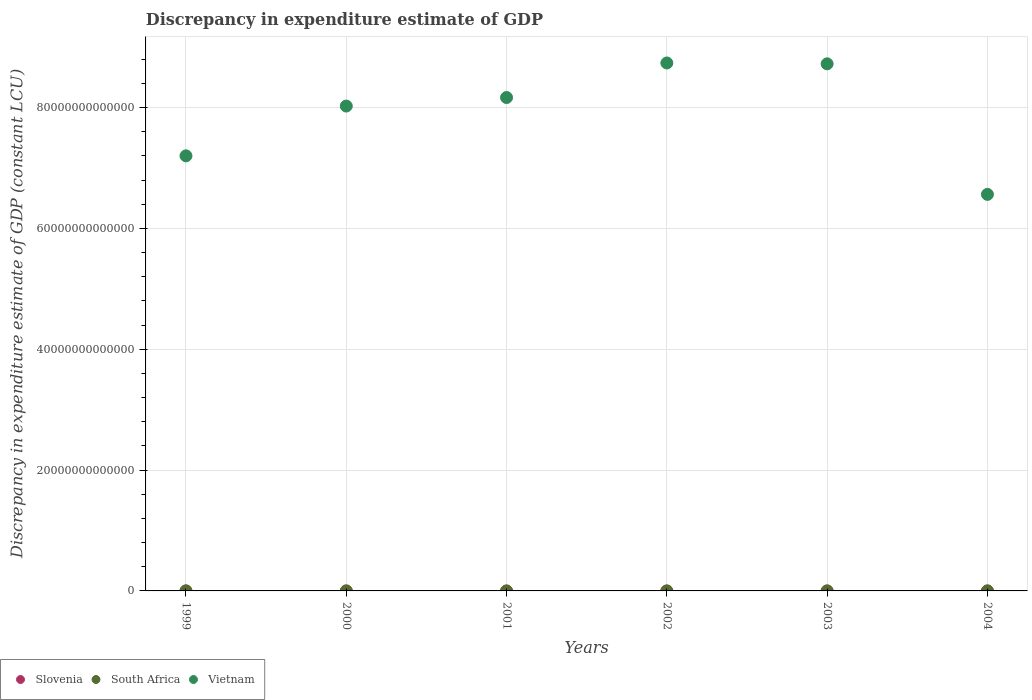What is the discrepancy in expenditure estimate of GDP in Slovenia in 2000?
Your answer should be compact. 0. Across all years, what is the maximum discrepancy in expenditure estimate of GDP in South Africa?
Your answer should be compact. 1.17e+09. What is the total discrepancy in expenditure estimate of GDP in Slovenia in the graph?
Your answer should be very brief. 0. What is the difference between the discrepancy in expenditure estimate of GDP in Vietnam in 2002 and that in 2003?
Give a very brief answer. 1.40e+11. What is the difference between the discrepancy in expenditure estimate of GDP in Slovenia in 2002 and the discrepancy in expenditure estimate of GDP in South Africa in 2001?
Provide a succinct answer. 0. What is the average discrepancy in expenditure estimate of GDP in South Africa per year?
Provide a succinct answer. 1.95e+08. What is the ratio of the discrepancy in expenditure estimate of GDP in Vietnam in 2002 to that in 2003?
Make the answer very short. 1. Is the discrepancy in expenditure estimate of GDP in Vietnam in 2001 less than that in 2004?
Offer a terse response. No. What is the difference between the highest and the second highest discrepancy in expenditure estimate of GDP in Vietnam?
Provide a succinct answer. 1.40e+11. What is the difference between the highest and the lowest discrepancy in expenditure estimate of GDP in South Africa?
Your response must be concise. 1.17e+09. In how many years, is the discrepancy in expenditure estimate of GDP in Slovenia greater than the average discrepancy in expenditure estimate of GDP in Slovenia taken over all years?
Make the answer very short. 0. Does the discrepancy in expenditure estimate of GDP in Vietnam monotonically increase over the years?
Ensure brevity in your answer.  No. Is the discrepancy in expenditure estimate of GDP in Slovenia strictly greater than the discrepancy in expenditure estimate of GDP in Vietnam over the years?
Give a very brief answer. No. How many dotlines are there?
Make the answer very short. 2. How many years are there in the graph?
Your response must be concise. 6. What is the difference between two consecutive major ticks on the Y-axis?
Your answer should be very brief. 2.00e+13. Are the values on the major ticks of Y-axis written in scientific E-notation?
Make the answer very short. No. Does the graph contain any zero values?
Offer a very short reply. Yes. How are the legend labels stacked?
Provide a short and direct response. Horizontal. What is the title of the graph?
Provide a short and direct response. Discrepancy in expenditure estimate of GDP. Does "Sint Maarten (Dutch part)" appear as one of the legend labels in the graph?
Ensure brevity in your answer.  No. What is the label or title of the Y-axis?
Provide a succinct answer. Discrepancy in expenditure estimate of GDP (constant LCU). What is the Discrepancy in expenditure estimate of GDP (constant LCU) in South Africa in 1999?
Offer a terse response. 1.17e+09. What is the Discrepancy in expenditure estimate of GDP (constant LCU) in Vietnam in 1999?
Give a very brief answer. 7.20e+13. What is the Discrepancy in expenditure estimate of GDP (constant LCU) in Slovenia in 2000?
Make the answer very short. 0. What is the Discrepancy in expenditure estimate of GDP (constant LCU) of Vietnam in 2000?
Your answer should be compact. 8.02e+13. What is the Discrepancy in expenditure estimate of GDP (constant LCU) of Slovenia in 2001?
Your response must be concise. 0. What is the Discrepancy in expenditure estimate of GDP (constant LCU) of Vietnam in 2001?
Give a very brief answer. 8.16e+13. What is the Discrepancy in expenditure estimate of GDP (constant LCU) of Vietnam in 2002?
Offer a terse response. 8.74e+13. What is the Discrepancy in expenditure estimate of GDP (constant LCU) of Slovenia in 2003?
Your response must be concise. 0. What is the Discrepancy in expenditure estimate of GDP (constant LCU) in Vietnam in 2003?
Your answer should be very brief. 8.72e+13. What is the Discrepancy in expenditure estimate of GDP (constant LCU) of South Africa in 2004?
Offer a very short reply. 0. What is the Discrepancy in expenditure estimate of GDP (constant LCU) in Vietnam in 2004?
Your response must be concise. 6.56e+13. Across all years, what is the maximum Discrepancy in expenditure estimate of GDP (constant LCU) in South Africa?
Provide a short and direct response. 1.17e+09. Across all years, what is the maximum Discrepancy in expenditure estimate of GDP (constant LCU) of Vietnam?
Provide a succinct answer. 8.74e+13. Across all years, what is the minimum Discrepancy in expenditure estimate of GDP (constant LCU) in South Africa?
Keep it short and to the point. 0. Across all years, what is the minimum Discrepancy in expenditure estimate of GDP (constant LCU) of Vietnam?
Your answer should be compact. 6.56e+13. What is the total Discrepancy in expenditure estimate of GDP (constant LCU) of Slovenia in the graph?
Ensure brevity in your answer.  0. What is the total Discrepancy in expenditure estimate of GDP (constant LCU) in South Africa in the graph?
Your response must be concise. 1.17e+09. What is the total Discrepancy in expenditure estimate of GDP (constant LCU) of Vietnam in the graph?
Keep it short and to the point. 4.74e+14. What is the difference between the Discrepancy in expenditure estimate of GDP (constant LCU) of Vietnam in 1999 and that in 2000?
Offer a terse response. -8.24e+12. What is the difference between the Discrepancy in expenditure estimate of GDP (constant LCU) of Vietnam in 1999 and that in 2001?
Provide a short and direct response. -9.65e+12. What is the difference between the Discrepancy in expenditure estimate of GDP (constant LCU) of Vietnam in 1999 and that in 2002?
Offer a terse response. -1.54e+13. What is the difference between the Discrepancy in expenditure estimate of GDP (constant LCU) in Vietnam in 1999 and that in 2003?
Ensure brevity in your answer.  -1.52e+13. What is the difference between the Discrepancy in expenditure estimate of GDP (constant LCU) of Vietnam in 1999 and that in 2004?
Offer a very short reply. 6.38e+12. What is the difference between the Discrepancy in expenditure estimate of GDP (constant LCU) in Vietnam in 2000 and that in 2001?
Give a very brief answer. -1.41e+12. What is the difference between the Discrepancy in expenditure estimate of GDP (constant LCU) in Vietnam in 2000 and that in 2002?
Ensure brevity in your answer.  -7.13e+12. What is the difference between the Discrepancy in expenditure estimate of GDP (constant LCU) of Vietnam in 2000 and that in 2003?
Give a very brief answer. -6.99e+12. What is the difference between the Discrepancy in expenditure estimate of GDP (constant LCU) of Vietnam in 2000 and that in 2004?
Give a very brief answer. 1.46e+13. What is the difference between the Discrepancy in expenditure estimate of GDP (constant LCU) in Vietnam in 2001 and that in 2002?
Give a very brief answer. -5.72e+12. What is the difference between the Discrepancy in expenditure estimate of GDP (constant LCU) in Vietnam in 2001 and that in 2003?
Give a very brief answer. -5.58e+12. What is the difference between the Discrepancy in expenditure estimate of GDP (constant LCU) in Vietnam in 2001 and that in 2004?
Keep it short and to the point. 1.60e+13. What is the difference between the Discrepancy in expenditure estimate of GDP (constant LCU) in Vietnam in 2002 and that in 2003?
Provide a succinct answer. 1.40e+11. What is the difference between the Discrepancy in expenditure estimate of GDP (constant LCU) of Vietnam in 2002 and that in 2004?
Your answer should be very brief. 2.17e+13. What is the difference between the Discrepancy in expenditure estimate of GDP (constant LCU) of Vietnam in 2003 and that in 2004?
Provide a succinct answer. 2.16e+13. What is the difference between the Discrepancy in expenditure estimate of GDP (constant LCU) in South Africa in 1999 and the Discrepancy in expenditure estimate of GDP (constant LCU) in Vietnam in 2000?
Offer a terse response. -8.02e+13. What is the difference between the Discrepancy in expenditure estimate of GDP (constant LCU) in South Africa in 1999 and the Discrepancy in expenditure estimate of GDP (constant LCU) in Vietnam in 2001?
Your answer should be compact. -8.16e+13. What is the difference between the Discrepancy in expenditure estimate of GDP (constant LCU) of South Africa in 1999 and the Discrepancy in expenditure estimate of GDP (constant LCU) of Vietnam in 2002?
Your response must be concise. -8.74e+13. What is the difference between the Discrepancy in expenditure estimate of GDP (constant LCU) in South Africa in 1999 and the Discrepancy in expenditure estimate of GDP (constant LCU) in Vietnam in 2003?
Offer a terse response. -8.72e+13. What is the difference between the Discrepancy in expenditure estimate of GDP (constant LCU) in South Africa in 1999 and the Discrepancy in expenditure estimate of GDP (constant LCU) in Vietnam in 2004?
Your answer should be very brief. -6.56e+13. What is the average Discrepancy in expenditure estimate of GDP (constant LCU) in South Africa per year?
Provide a short and direct response. 1.95e+08. What is the average Discrepancy in expenditure estimate of GDP (constant LCU) in Vietnam per year?
Offer a very short reply. 7.90e+13. In the year 1999, what is the difference between the Discrepancy in expenditure estimate of GDP (constant LCU) of South Africa and Discrepancy in expenditure estimate of GDP (constant LCU) of Vietnam?
Provide a succinct answer. -7.20e+13. What is the ratio of the Discrepancy in expenditure estimate of GDP (constant LCU) in Vietnam in 1999 to that in 2000?
Keep it short and to the point. 0.9. What is the ratio of the Discrepancy in expenditure estimate of GDP (constant LCU) of Vietnam in 1999 to that in 2001?
Make the answer very short. 0.88. What is the ratio of the Discrepancy in expenditure estimate of GDP (constant LCU) in Vietnam in 1999 to that in 2002?
Offer a terse response. 0.82. What is the ratio of the Discrepancy in expenditure estimate of GDP (constant LCU) in Vietnam in 1999 to that in 2003?
Offer a very short reply. 0.83. What is the ratio of the Discrepancy in expenditure estimate of GDP (constant LCU) in Vietnam in 1999 to that in 2004?
Make the answer very short. 1.1. What is the ratio of the Discrepancy in expenditure estimate of GDP (constant LCU) of Vietnam in 2000 to that in 2001?
Provide a short and direct response. 0.98. What is the ratio of the Discrepancy in expenditure estimate of GDP (constant LCU) in Vietnam in 2000 to that in 2002?
Offer a terse response. 0.92. What is the ratio of the Discrepancy in expenditure estimate of GDP (constant LCU) in Vietnam in 2000 to that in 2003?
Your answer should be very brief. 0.92. What is the ratio of the Discrepancy in expenditure estimate of GDP (constant LCU) of Vietnam in 2000 to that in 2004?
Provide a short and direct response. 1.22. What is the ratio of the Discrepancy in expenditure estimate of GDP (constant LCU) of Vietnam in 2001 to that in 2002?
Keep it short and to the point. 0.93. What is the ratio of the Discrepancy in expenditure estimate of GDP (constant LCU) in Vietnam in 2001 to that in 2003?
Provide a short and direct response. 0.94. What is the ratio of the Discrepancy in expenditure estimate of GDP (constant LCU) in Vietnam in 2001 to that in 2004?
Your response must be concise. 1.24. What is the ratio of the Discrepancy in expenditure estimate of GDP (constant LCU) of Vietnam in 2002 to that in 2004?
Ensure brevity in your answer.  1.33. What is the ratio of the Discrepancy in expenditure estimate of GDP (constant LCU) in Vietnam in 2003 to that in 2004?
Provide a short and direct response. 1.33. What is the difference between the highest and the second highest Discrepancy in expenditure estimate of GDP (constant LCU) of Vietnam?
Make the answer very short. 1.40e+11. What is the difference between the highest and the lowest Discrepancy in expenditure estimate of GDP (constant LCU) in South Africa?
Your answer should be compact. 1.17e+09. What is the difference between the highest and the lowest Discrepancy in expenditure estimate of GDP (constant LCU) in Vietnam?
Keep it short and to the point. 2.17e+13. 